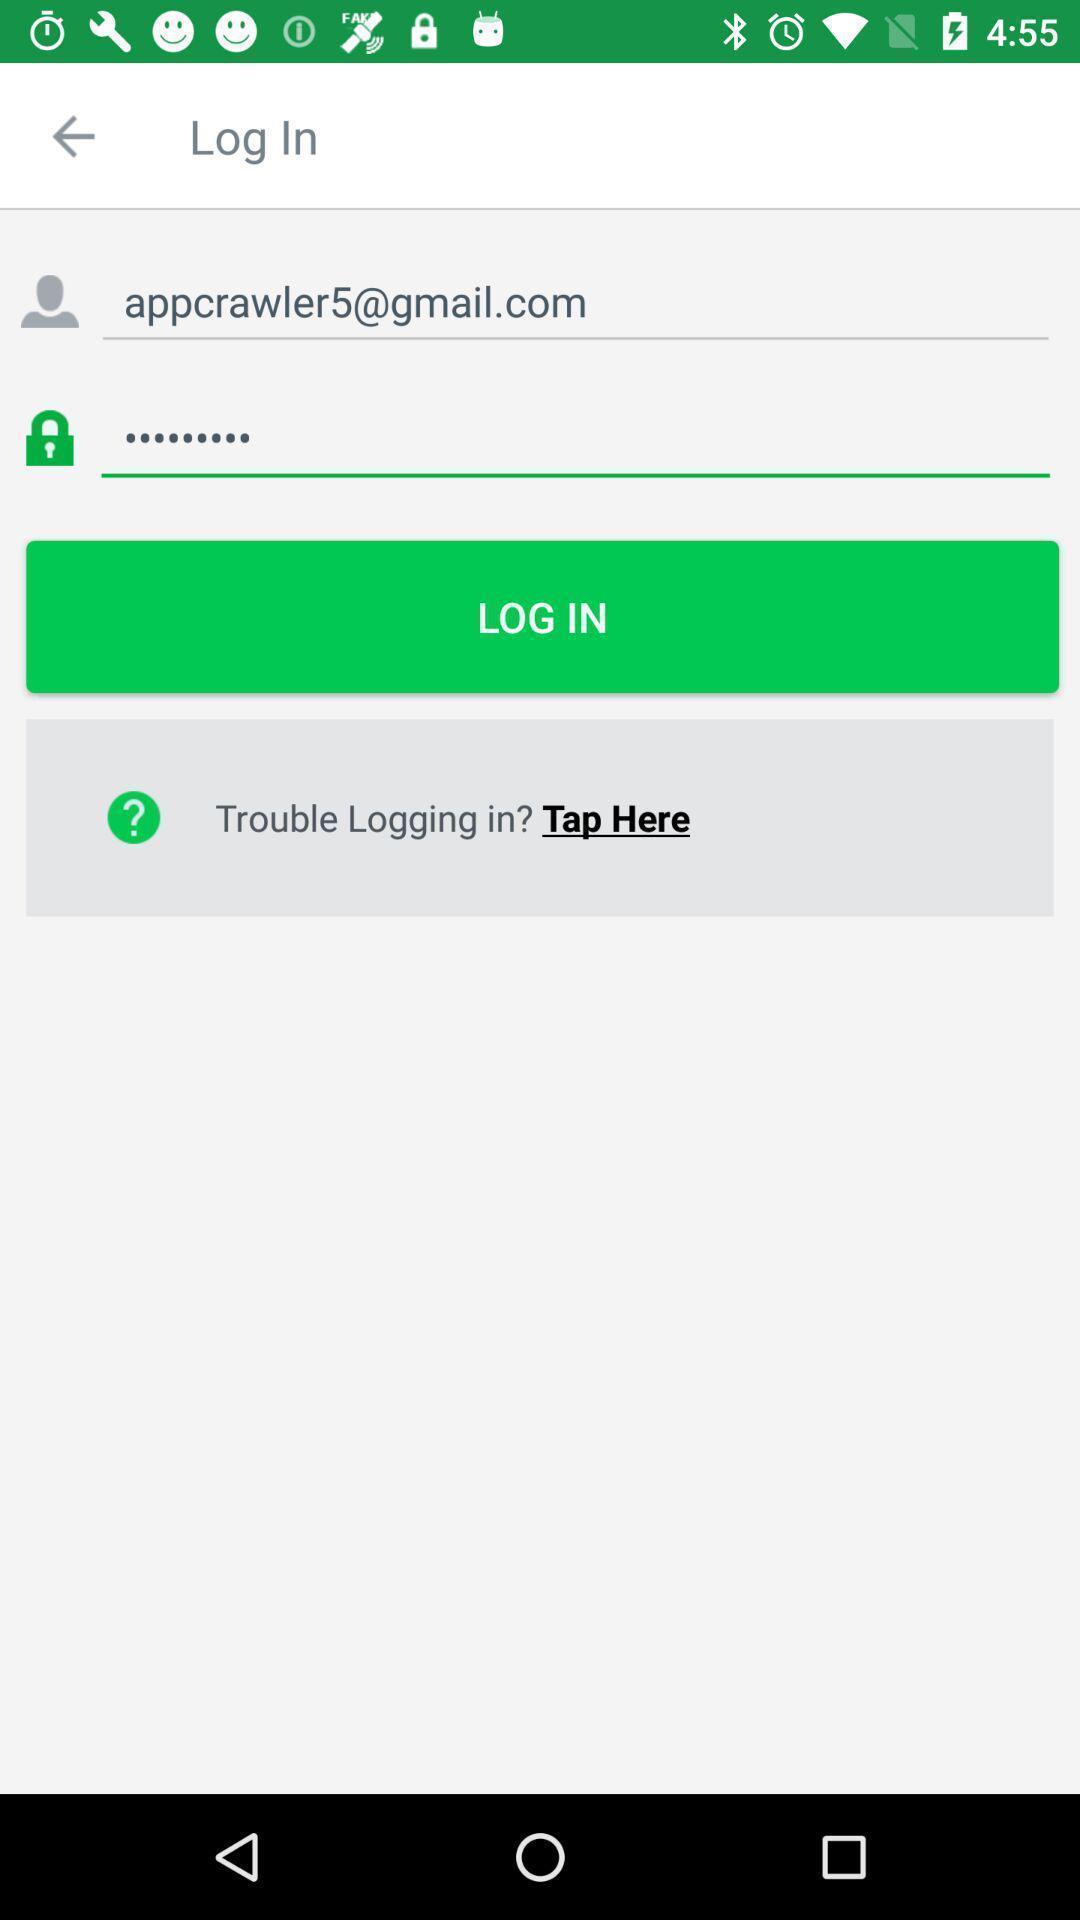Summarize the information in this screenshot. Screen displaying the login page. 